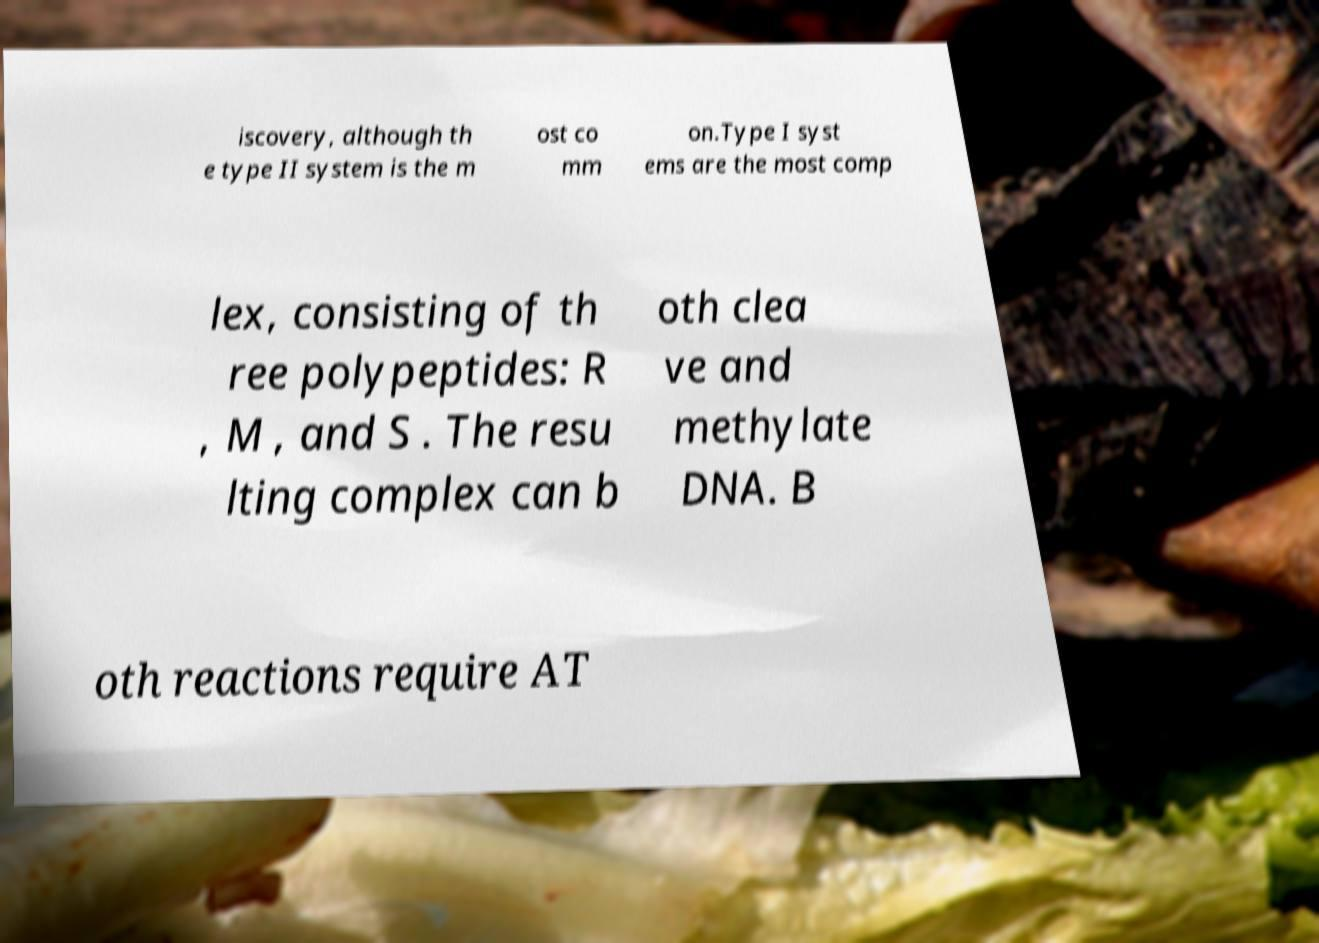Can you accurately transcribe the text from the provided image for me? iscovery, although th e type II system is the m ost co mm on.Type I syst ems are the most comp lex, consisting of th ree polypeptides: R , M , and S . The resu lting complex can b oth clea ve and methylate DNA. B oth reactions require AT 